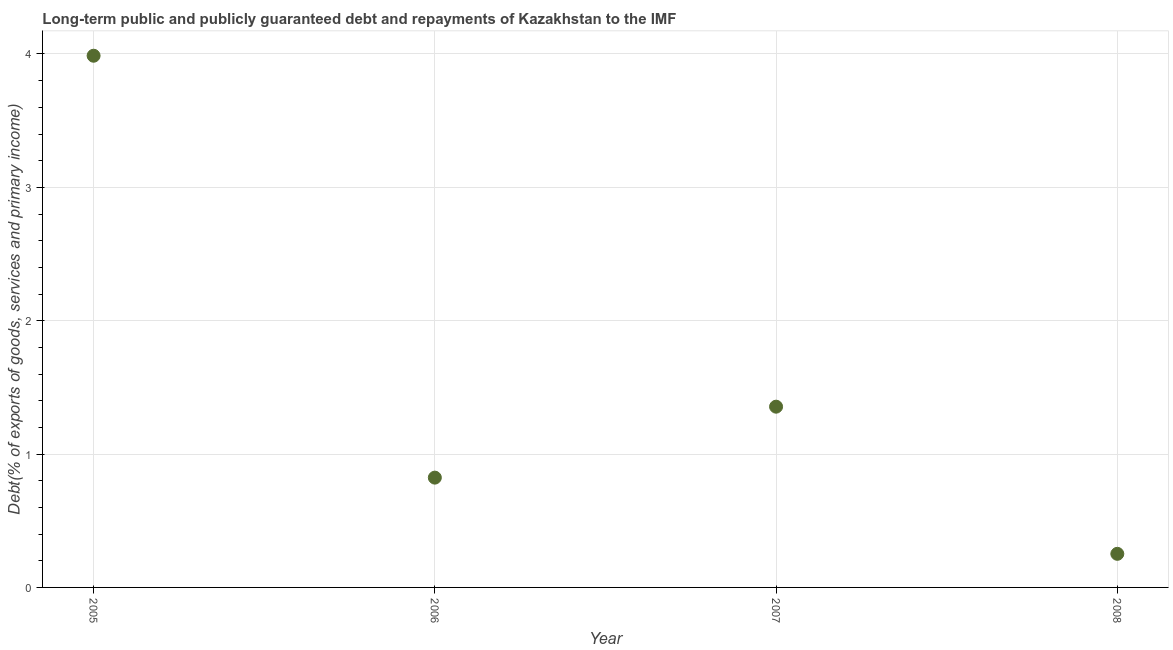What is the debt service in 2007?
Make the answer very short. 1.36. Across all years, what is the maximum debt service?
Give a very brief answer. 3.99. Across all years, what is the minimum debt service?
Keep it short and to the point. 0.25. In which year was the debt service maximum?
Your answer should be compact. 2005. What is the sum of the debt service?
Keep it short and to the point. 6.42. What is the difference between the debt service in 2006 and 2007?
Keep it short and to the point. -0.53. What is the average debt service per year?
Offer a very short reply. 1.6. What is the median debt service?
Offer a very short reply. 1.09. In how many years, is the debt service greater than 2 %?
Offer a very short reply. 1. What is the ratio of the debt service in 2005 to that in 2008?
Keep it short and to the point. 15.82. Is the difference between the debt service in 2006 and 2008 greater than the difference between any two years?
Offer a very short reply. No. What is the difference between the highest and the second highest debt service?
Ensure brevity in your answer.  2.63. Is the sum of the debt service in 2005 and 2008 greater than the maximum debt service across all years?
Offer a very short reply. Yes. What is the difference between the highest and the lowest debt service?
Make the answer very short. 3.74. How many years are there in the graph?
Offer a terse response. 4. What is the difference between two consecutive major ticks on the Y-axis?
Your answer should be compact. 1. Does the graph contain any zero values?
Keep it short and to the point. No. Does the graph contain grids?
Your response must be concise. Yes. What is the title of the graph?
Ensure brevity in your answer.  Long-term public and publicly guaranteed debt and repayments of Kazakhstan to the IMF. What is the label or title of the Y-axis?
Your answer should be compact. Debt(% of exports of goods, services and primary income). What is the Debt(% of exports of goods, services and primary income) in 2005?
Make the answer very short. 3.99. What is the Debt(% of exports of goods, services and primary income) in 2006?
Provide a succinct answer. 0.82. What is the Debt(% of exports of goods, services and primary income) in 2007?
Your answer should be compact. 1.36. What is the Debt(% of exports of goods, services and primary income) in 2008?
Offer a terse response. 0.25. What is the difference between the Debt(% of exports of goods, services and primary income) in 2005 and 2006?
Offer a terse response. 3.16. What is the difference between the Debt(% of exports of goods, services and primary income) in 2005 and 2007?
Your answer should be compact. 2.63. What is the difference between the Debt(% of exports of goods, services and primary income) in 2005 and 2008?
Provide a succinct answer. 3.74. What is the difference between the Debt(% of exports of goods, services and primary income) in 2006 and 2007?
Offer a very short reply. -0.53. What is the difference between the Debt(% of exports of goods, services and primary income) in 2006 and 2008?
Ensure brevity in your answer.  0.57. What is the difference between the Debt(% of exports of goods, services and primary income) in 2007 and 2008?
Your response must be concise. 1.1. What is the ratio of the Debt(% of exports of goods, services and primary income) in 2005 to that in 2006?
Your answer should be very brief. 4.84. What is the ratio of the Debt(% of exports of goods, services and primary income) in 2005 to that in 2007?
Offer a terse response. 2.94. What is the ratio of the Debt(% of exports of goods, services and primary income) in 2005 to that in 2008?
Provide a succinct answer. 15.82. What is the ratio of the Debt(% of exports of goods, services and primary income) in 2006 to that in 2007?
Give a very brief answer. 0.61. What is the ratio of the Debt(% of exports of goods, services and primary income) in 2006 to that in 2008?
Keep it short and to the point. 3.27. What is the ratio of the Debt(% of exports of goods, services and primary income) in 2007 to that in 2008?
Provide a succinct answer. 5.38. 